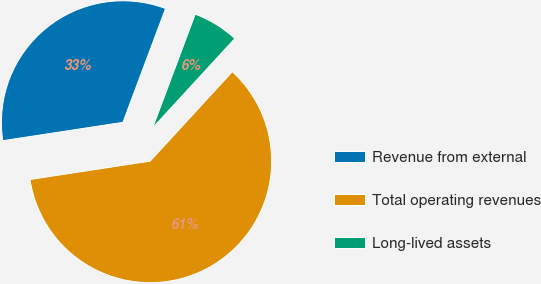Convert chart to OTSL. <chart><loc_0><loc_0><loc_500><loc_500><pie_chart><fcel>Revenue from external<fcel>Total operating revenues<fcel>Long-lived assets<nl><fcel>33.12%<fcel>60.75%<fcel>6.13%<nl></chart> 